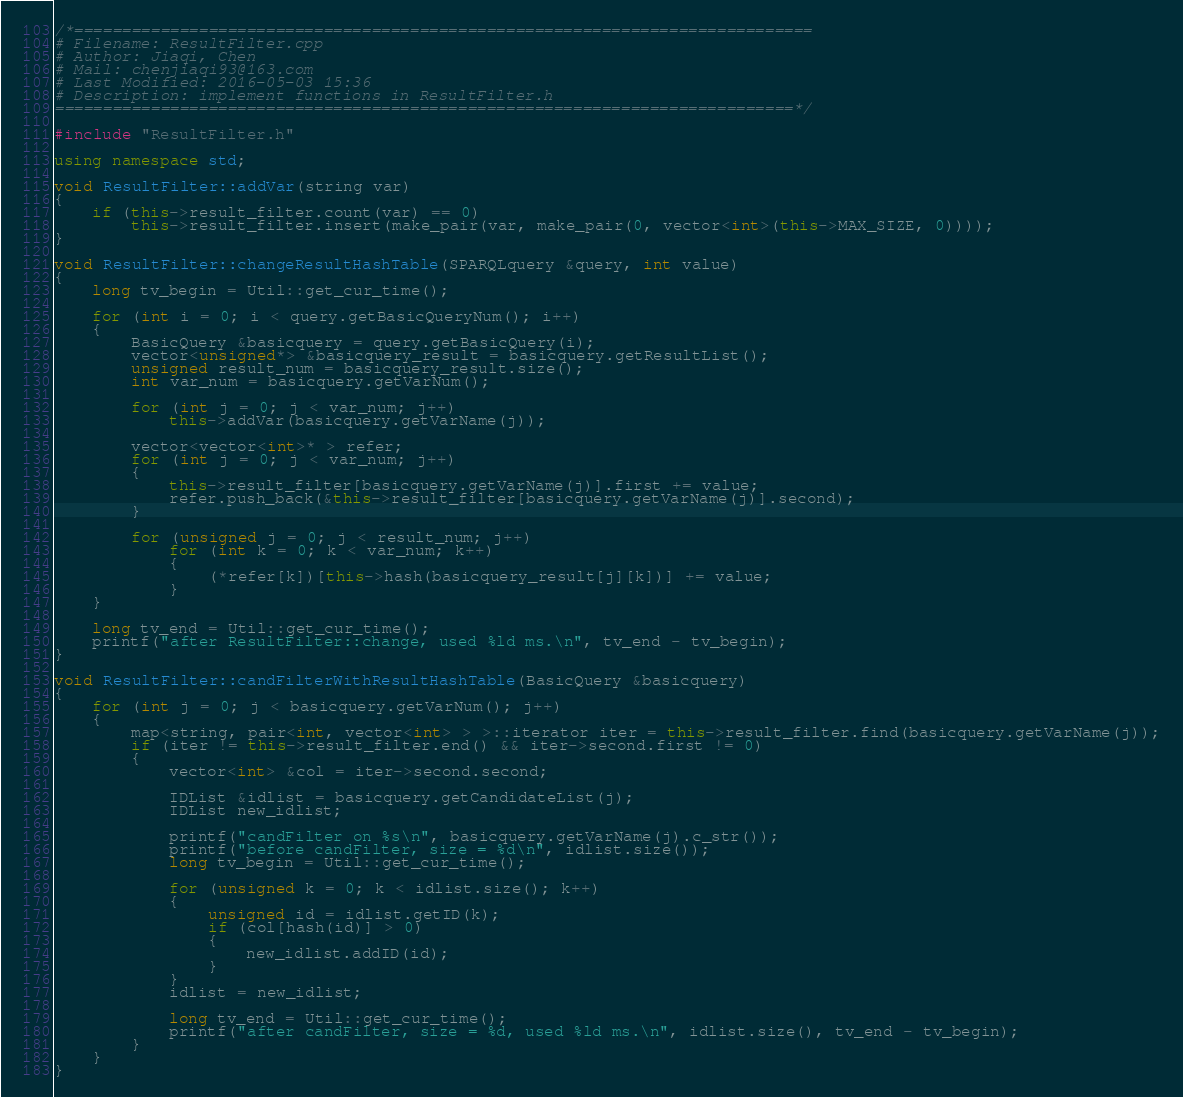Convert code to text. <code><loc_0><loc_0><loc_500><loc_500><_C++_>/*=============================================================================
# Filename: ResultFilter.cpp
# Author: Jiaqi, Chen
# Mail: chenjiaqi93@163.com
# Last Modified: 2016-05-03 15:36
# Description: implement functions in ResultFilter.h
=============================================================================*/

#include "ResultFilter.h"

using namespace std;

void ResultFilter::addVar(string var)
{
	if (this->result_filter.count(var) == 0)
		this->result_filter.insert(make_pair(var, make_pair(0, vector<int>(this->MAX_SIZE, 0))));
}

void ResultFilter::changeResultHashTable(SPARQLquery &query, int value)
{
    long tv_begin = Util::get_cur_time();

	for (int i = 0; i < query.getBasicQueryNum(); i++)
	{
		BasicQuery &basicquery = query.getBasicQuery(i);
		vector<unsigned*> &basicquery_result = basicquery.getResultList();
		unsigned result_num = basicquery_result.size();
		int var_num = basicquery.getVarNum();

		for (int j = 0; j < var_num; j++)
			this->addVar(basicquery.getVarName(j));

		vector<vector<int>* > refer;
		for (int j = 0; j < var_num; j++)
		{
			this->result_filter[basicquery.getVarName(j)].first += value;
			refer.push_back(&this->result_filter[basicquery.getVarName(j)].second);
		}

		for (unsigned j = 0; j < result_num; j++)
			for (int k = 0; k < var_num; k++)
			{
				(*refer[k])[this->hash(basicquery_result[j][k])] += value;
			}
	}

    long tv_end = Util::get_cur_time();
	printf("after ResultFilter::change, used %ld ms.\n", tv_end - tv_begin);
}

void ResultFilter::candFilterWithResultHashTable(BasicQuery &basicquery)
{
	for (int j = 0; j < basicquery.getVarNum(); j++)
	{
		map<string, pair<int, vector<int> > >::iterator iter = this->result_filter.find(basicquery.getVarName(j));
		if (iter != this->result_filter.end() && iter->second.first != 0)
		{
			vector<int> &col = iter->second.second;

			IDList &idlist = basicquery.getCandidateList(j);
			IDList new_idlist;

			printf("candFilter on %s\n", basicquery.getVarName(j).c_str());
			printf("before candFilter, size = %d\n", idlist.size());
		    long tv_begin = Util::get_cur_time();

			for (unsigned k = 0; k < idlist.size(); k++)
			{
				unsigned id = idlist.getID(k);
				if (col[hash(id)] > 0)
				{
					new_idlist.addID(id);
				}
			}
			idlist = new_idlist;

		    long tv_end = Util::get_cur_time();
			printf("after candFilter, size = %d, used %ld ms.\n", idlist.size(), tv_end - tv_begin);
		}
	}
}
</code> 